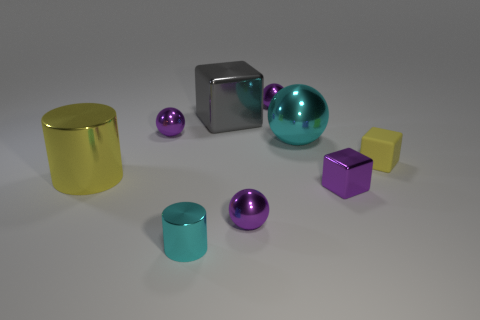Which objects in the image are reflecting light most prominently? The objects that appear to be reflecting light the most prominently are the silver cube and the larger spheres. These objects have reflective surfaces that catch the light, highlighting their shiny textures. 